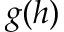<formula> <loc_0><loc_0><loc_500><loc_500>g ( h )</formula> 